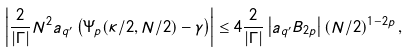Convert formula to latex. <formula><loc_0><loc_0><loc_500><loc_500>\left | \frac { 2 } { \left | \Gamma \right | } N ^ { 2 } a _ { q ^ { \prime } } \left ( \Psi _ { p } ( \kappa / 2 , N / 2 ) - \gamma \right ) \right | \leq 4 \frac { 2 } { \left | \Gamma \right | } \left | a _ { q ^ { \prime } } B _ { 2 p } \right | \left ( N / 2 \right ) ^ { 1 - 2 p } ,</formula> 